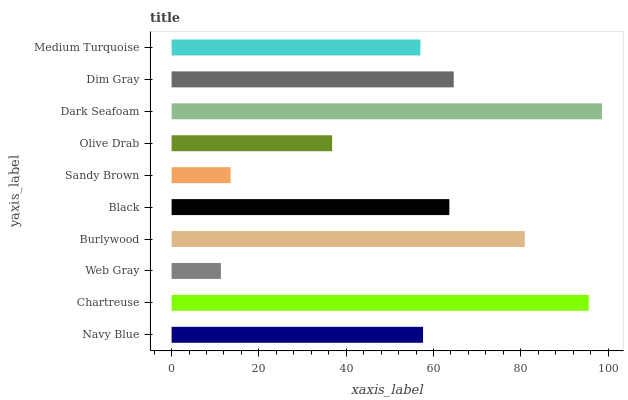Is Web Gray the minimum?
Answer yes or no. Yes. Is Dark Seafoam the maximum?
Answer yes or no. Yes. Is Chartreuse the minimum?
Answer yes or no. No. Is Chartreuse the maximum?
Answer yes or no. No. Is Chartreuse greater than Navy Blue?
Answer yes or no. Yes. Is Navy Blue less than Chartreuse?
Answer yes or no. Yes. Is Navy Blue greater than Chartreuse?
Answer yes or no. No. Is Chartreuse less than Navy Blue?
Answer yes or no. No. Is Black the high median?
Answer yes or no. Yes. Is Navy Blue the low median?
Answer yes or no. Yes. Is Dim Gray the high median?
Answer yes or no. No. Is Sandy Brown the low median?
Answer yes or no. No. 